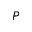<formula> <loc_0><loc_0><loc_500><loc_500>P</formula> 